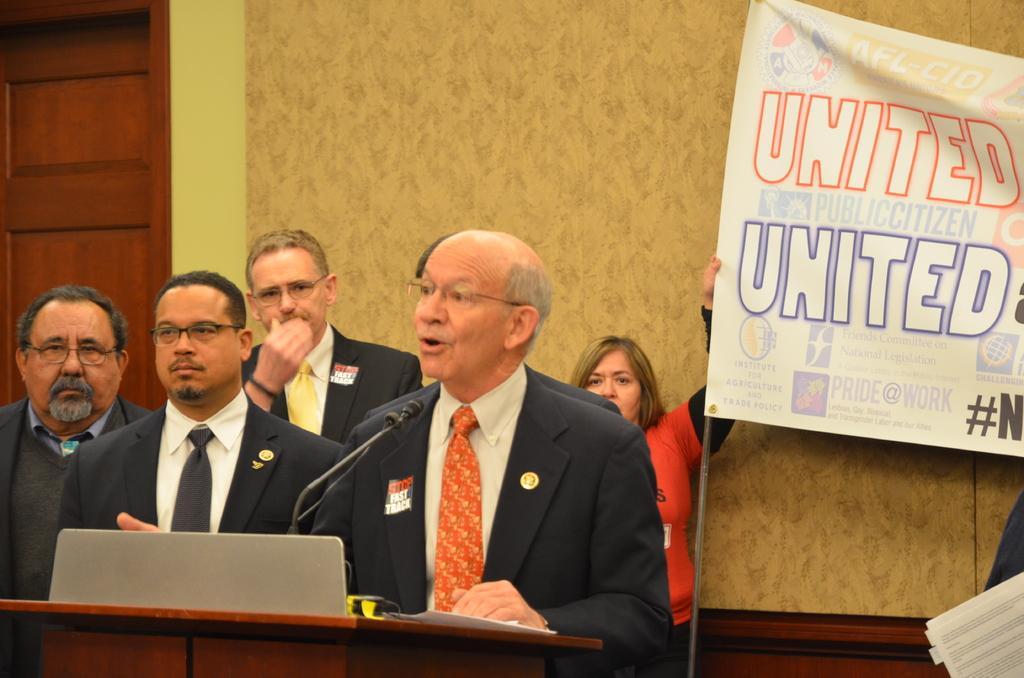Please provide a concise description of this image. Here I can see five men wearing suits and standing in front of the podium. One man is speaking on the microphone. At the back of these people there is a woman standing and holding a banner which consists of some text. In the background there is a curtain to the wall. On the left side there is a door. 